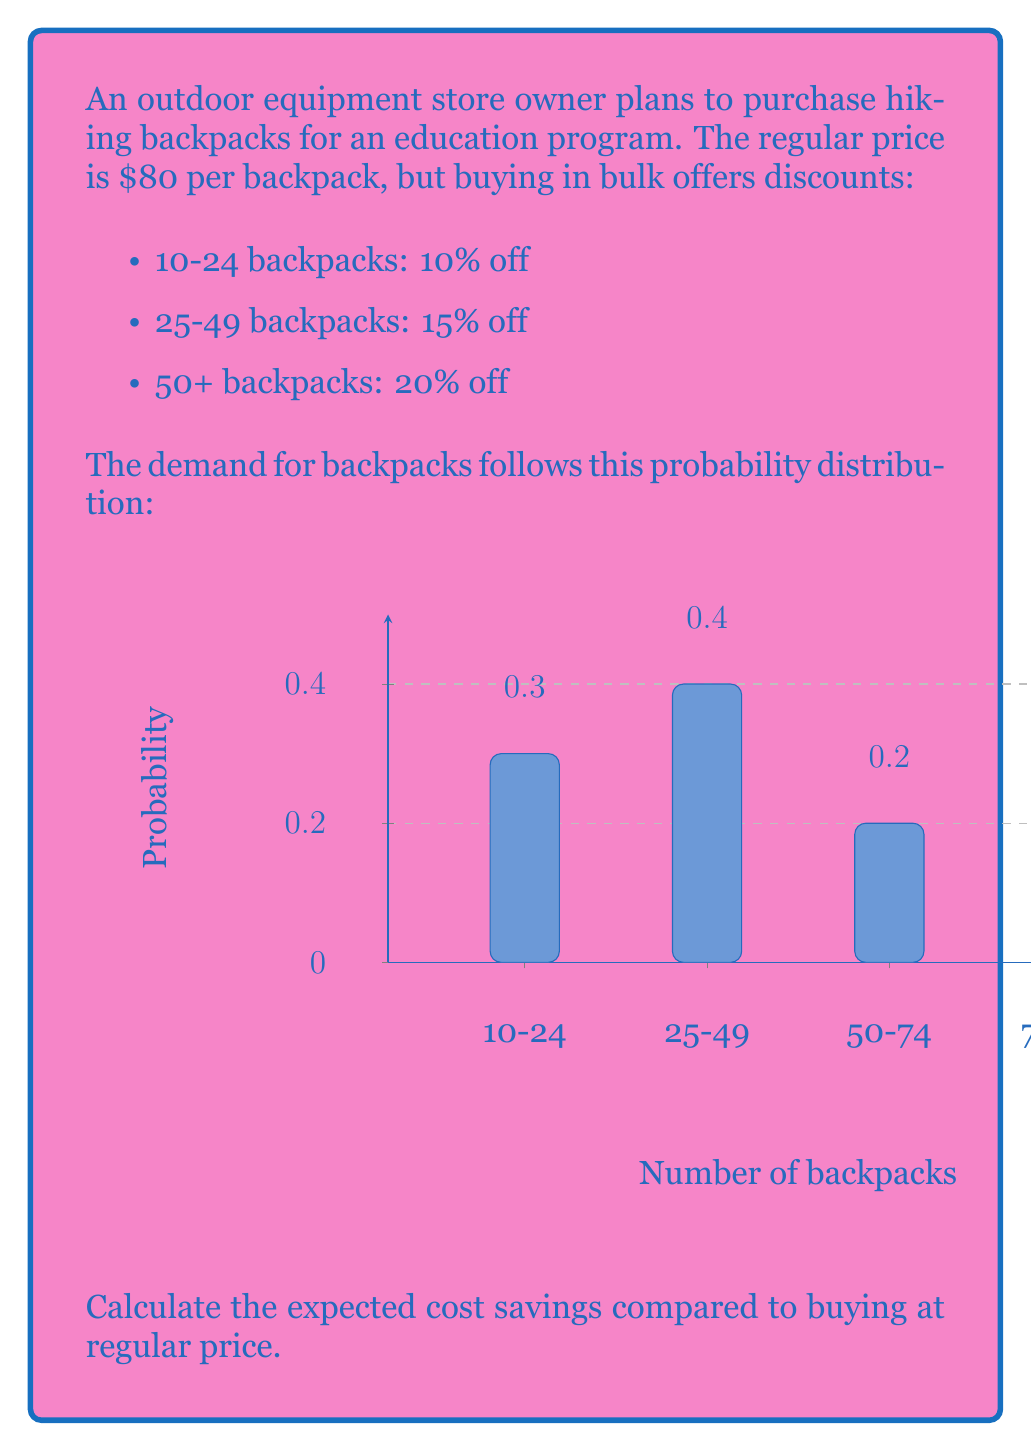Can you answer this question? Let's approach this step-by-step:

1) First, we need to calculate the cost for each range:

   10-24 backpacks: $80 * 0.9 = $72 per backpack
   25-49 backpacks: $80 * 0.85 = $68 per backpack
   50+ backpacks: $80 * 0.8 = $64 per backpack

2) Now, let's calculate the expected number of backpacks for each range:
   
   10-24: midpoint is 17, probability is 0.3
   25-49: midpoint is 37, probability is 0.4
   50-74: midpoint is 62, probability is 0.2
   75-100: midpoint is 87.5, probability is 0.1

3) Expected number of backpacks:
   
   $E(backpacks) = 17 * 0.3 + 37 * 0.4 + 62 * 0.2 + 87.5 * 0.1 = 39.95$

4) Expected cost at regular price:
   
   $E(regular) = 39.95 * $80 = $3,196$

5) Expected cost with bulk pricing:
   
   $E(bulk) = 17 * $72 * 0.3 + 37 * $68 * 0.4 + 62 * $64 * 0.2 + 87.5 * $64 * 0.1$
            $= 367.2 + 1,006.4 + 793.6 + 560 = $2,727.2$

6) Expected savings:
   
   $E(savings) = E(regular) - E(bulk) = $3,196 - $2,727.2 = $468.8$
Answer: $468.80 